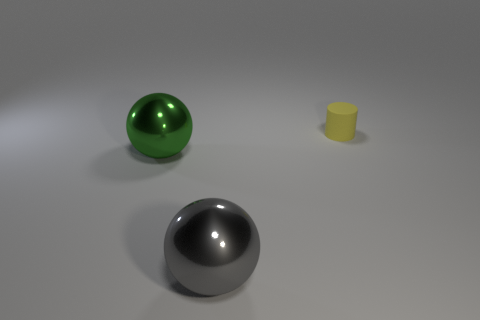There is a sphere right of the big green metal object; is there a big thing that is behind it? Behind the large green metallic sphere, there is no object of comparable size; only a smaller grey metal sphere is visible in the foreground. 